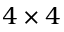<formula> <loc_0><loc_0><loc_500><loc_500>4 \times 4</formula> 